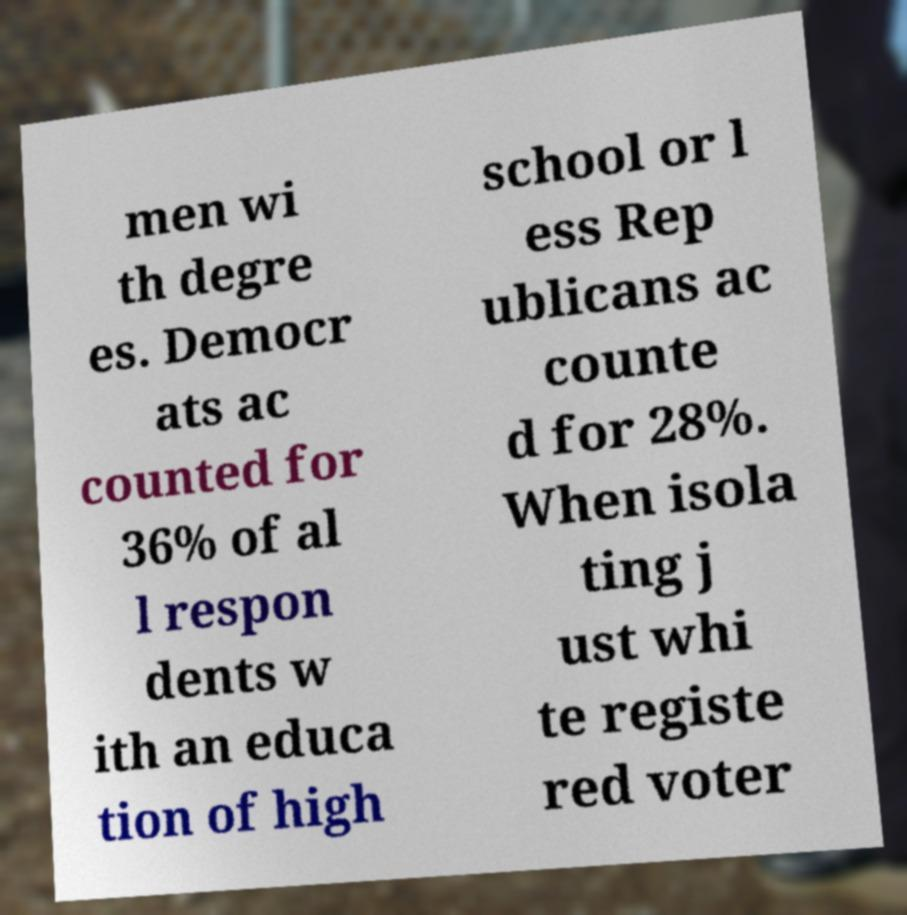I need the written content from this picture converted into text. Can you do that? men wi th degre es. Democr ats ac counted for 36% of al l respon dents w ith an educa tion of high school or l ess Rep ublicans ac counte d for 28%. When isola ting j ust whi te registe red voter 